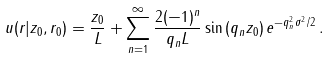Convert formula to latex. <formula><loc_0><loc_0><loc_500><loc_500>u ( r | z _ { 0 } , r _ { 0 } ) = \frac { z _ { 0 } } L + \sum _ { n = 1 } ^ { \infty } \frac { 2 ( - 1 ) ^ { n } } { q _ { n } L } \sin \left ( q _ { n } z _ { 0 } \right ) e ^ { - q _ { n } ^ { 2 } \sigma ^ { 2 } / 2 } \, .</formula> 